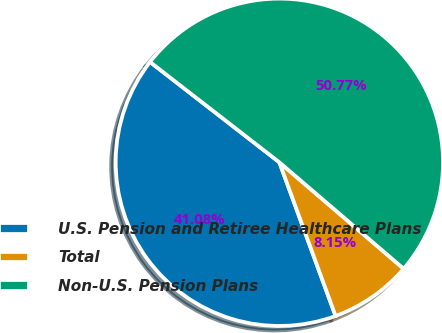<chart> <loc_0><loc_0><loc_500><loc_500><pie_chart><fcel>U.S. Pension and Retiree Healthcare Plans<fcel>Total<fcel>Non-U.S. Pension Plans<nl><fcel>41.08%<fcel>8.15%<fcel>50.77%<nl></chart> 